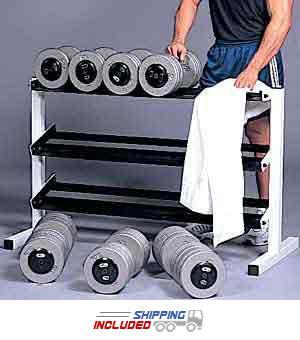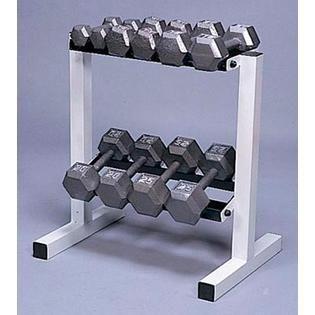The first image is the image on the left, the second image is the image on the right. Analyze the images presented: Is the assertion "There is a human near dumbells in one of the images." valid? Answer yes or no. Yes. The first image is the image on the left, the second image is the image on the right. Given the left and right images, does the statement "An image features a three-tiered rack containing dumbbells with hexagon-shaped weights." hold true? Answer yes or no. No. 